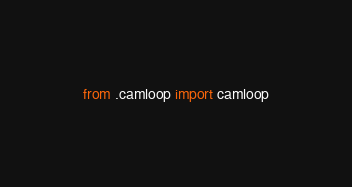Convert code to text. <code><loc_0><loc_0><loc_500><loc_500><_Python_>from .camloop import camloop
</code> 